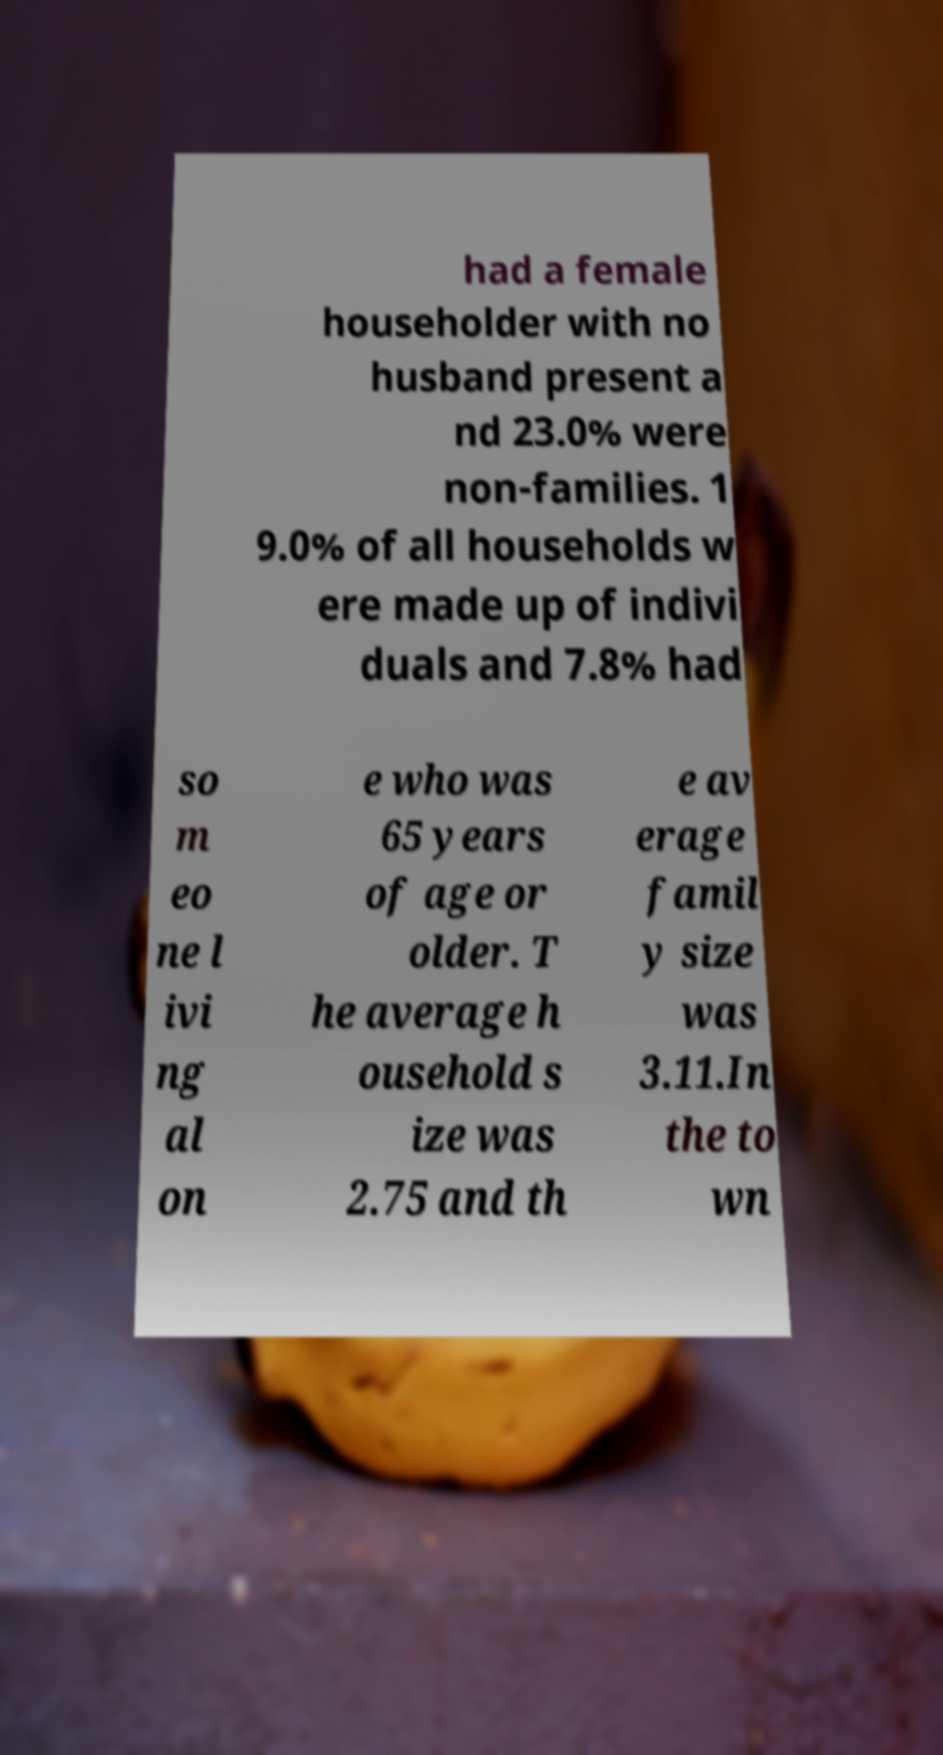Can you read and provide the text displayed in the image?This photo seems to have some interesting text. Can you extract and type it out for me? had a female householder with no husband present a nd 23.0% were non-families. 1 9.0% of all households w ere made up of indivi duals and 7.8% had so m eo ne l ivi ng al on e who was 65 years of age or older. T he average h ousehold s ize was 2.75 and th e av erage famil y size was 3.11.In the to wn 